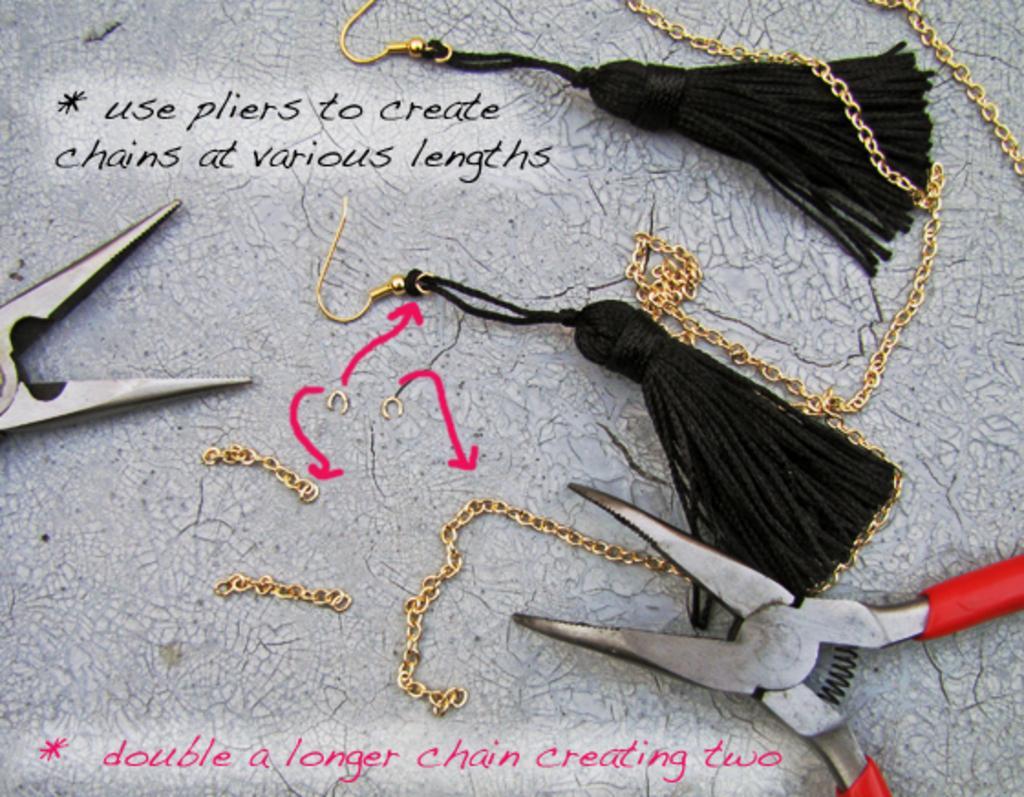Describe this image in one or two sentences. In this image we can see earrings, cutting player and a clip placed on the surface. There are chains and we can see text written. 